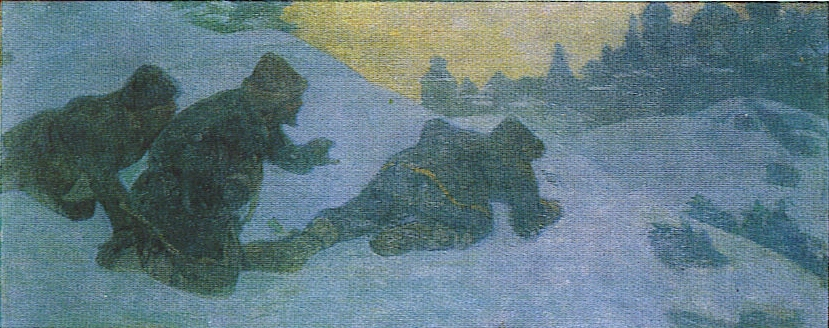Who are the figures in the image? The figures in the image are likely travelers or villagers making their way through an intense winter landscape. Given their traditional Russian attire, it can be inferred that they are from a historical or rural setting, possibly involved in daily activities such as hunting, gathering, or returning home. What time of day do you think it is in the image? The warm yellow glow in the background suggests that it could be either dawn or dusk. The soft light illuminating the snow and casting long shadows hints at the early morning or late afternoon, times typically characterized by a low angle of sunlight. 